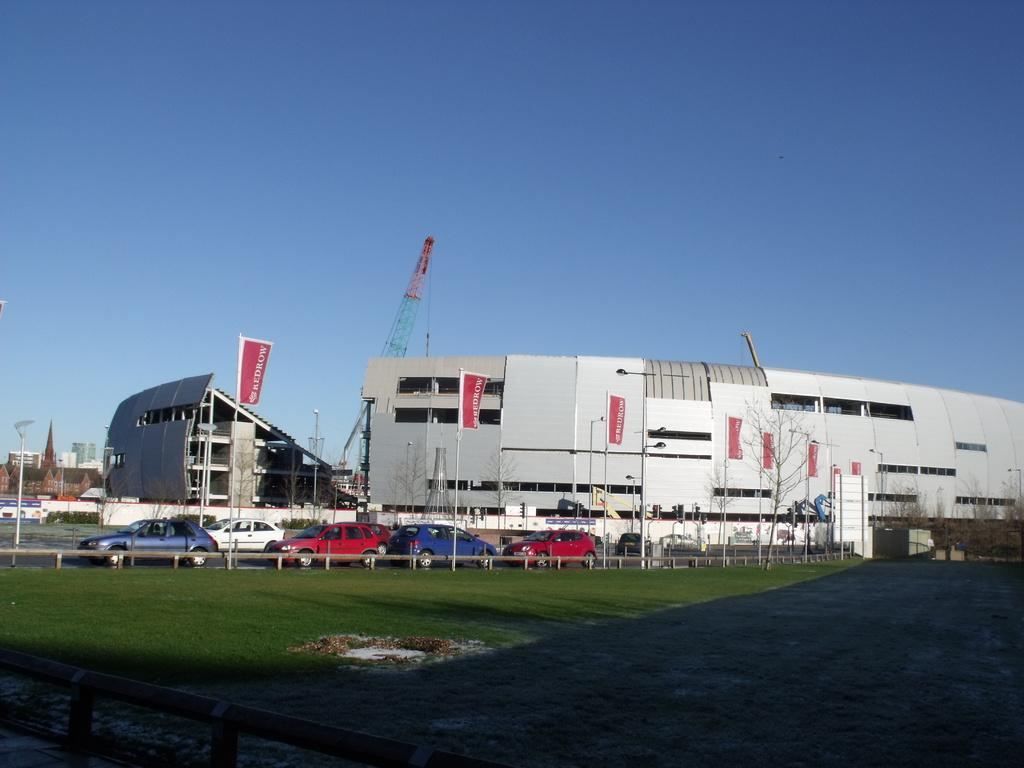What type of surface is visible in the image? There is ground visible in the image. What type of vegetation is present on the ground? There is grass on the ground. What can be seen on the road in the image? There are vehicles on the road. What is visible in the background of the image? There are trees, poles, buildings, and a crane visible in the background. What part of the sky is visible in the image? The sky is visible in the background of the image. Where are the grandmother and kittens playing in the image? There is no grandmother or kittens present in the image. What type of sticks are being used by the people in the image? There are no sticks visible in the image. 